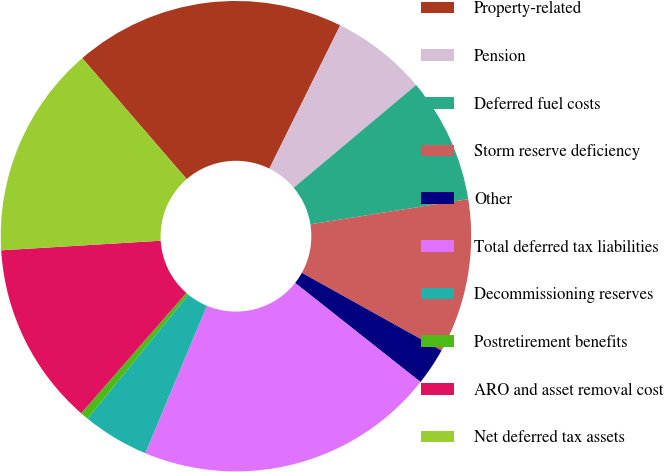Convert chart. <chart><loc_0><loc_0><loc_500><loc_500><pie_chart><fcel>Property-related<fcel>Pension<fcel>Deferred fuel costs<fcel>Storm reserve deficiency<fcel>Other<fcel>Total deferred tax liabilities<fcel>Decommissioning reserves<fcel>Postretirement benefits<fcel>ARO and asset removal cost<fcel>Net deferred tax assets<nl><fcel>18.64%<fcel>6.58%<fcel>8.59%<fcel>10.6%<fcel>2.56%<fcel>20.65%<fcel>4.57%<fcel>0.56%<fcel>12.61%<fcel>14.62%<nl></chart> 